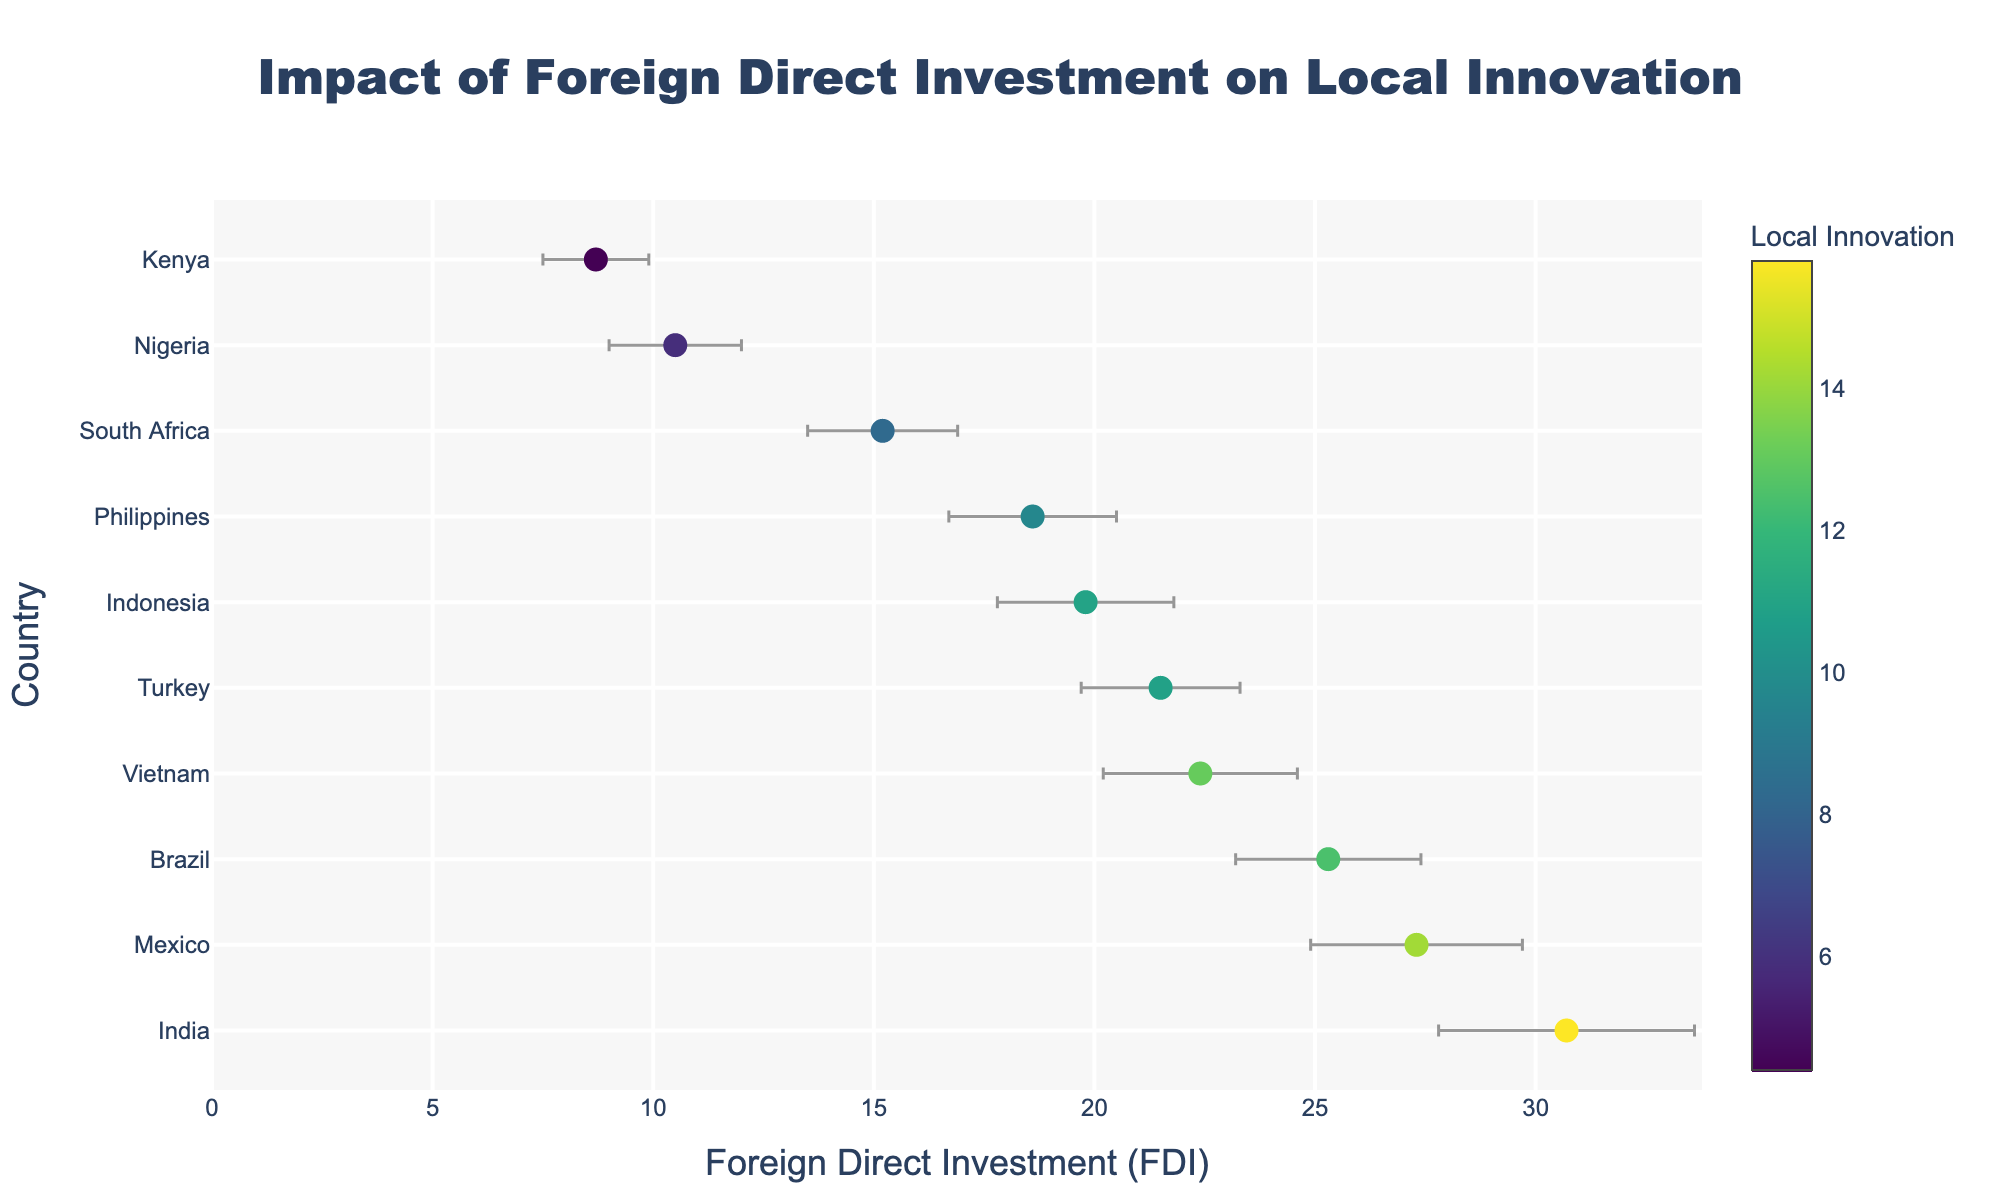Which country has the highest Foreign Direct Investment (FDI) value? To identify the country with the highest FDI, look at the figure and find the country whose dot is farthest to the right on the X-axis.
Answer: India What is the title of the plot? The title of the plot is typically located at the top of the figure in a larger, bold font.
Answer: Impact of Foreign Direct Investment on Local Innovation Which country has the smallest Local Innovation value? To determine the country with the smallest Local Innovation value, look at the color intensity on the dots. The dot with the least saturated color represents the smallest Local Innovation value.
Answer: Kenya What is the range of the Foreign Direct Investment (FDI) values represented in the plot? Find the minimum and maximum values on the X-axis. The minimum value is associated with the leftmost dot, and the maximum is associated with the rightmost dot.
Answer: 8.7 to 30.7 Which country exhibits the largest error margin in Foreign Direct Investment? Error margins are represented by the horizontal bars extending from each dot. The country with the longest error bar has the largest error margin.
Answer: India Which countries fall within an FDI range of 20 to 25? Identify the dots that fall between the 20 and 25 marks on the X-axis. Note the countries associated with these dots.
Answer: Vietnam, Turkey What is the average Local Innovation value for countries with FDI above 20? First, identify the Local Innovation values for countries with an FDI greater than 20. These are Brazil (12.5), India (15.8), Vietnam (13.1), Mexico (14.2), and Turkey (10.9). Calculate the average: (12.5 + 15.8 + 13.1 + 14.2 + 10.9) / 5.
Answer: 13.3 Comparing Mexico and Nigeria, which country has a higher Local Innovation value? Look at the color of the dots representing Mexico and Nigeria. The dot with a more saturated color (brighter/more intense) has a higher Local Innovation value.
Answer: Mexico For Brazil and Indonesia, which country has a smaller error margin? Compare the lengths of the error bars for Brazil and Indonesia. The country with the shorter error bar has a smaller error margin.
Answer: Brazil What is the sum of the error margins for South Africa and the Philippines? Locate the error margins for both South Africa (1.7) and the Philippines (1.9), then add these values together: 1.7 + 1.9.
Answer: 3.6 